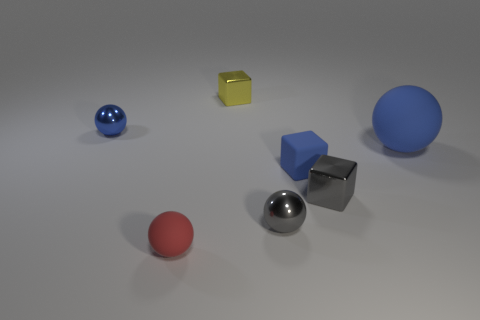How many objects are there in the image and can you describe their positions relative to each other? There are five objects in the image. Starting from the left, there is a blue sphere, a red sphere, and a large blue sphere. Positioned slightly toward the rear between these spheres is a metallic cube, while a yellow cube lies to the right of the metallic sphere. 